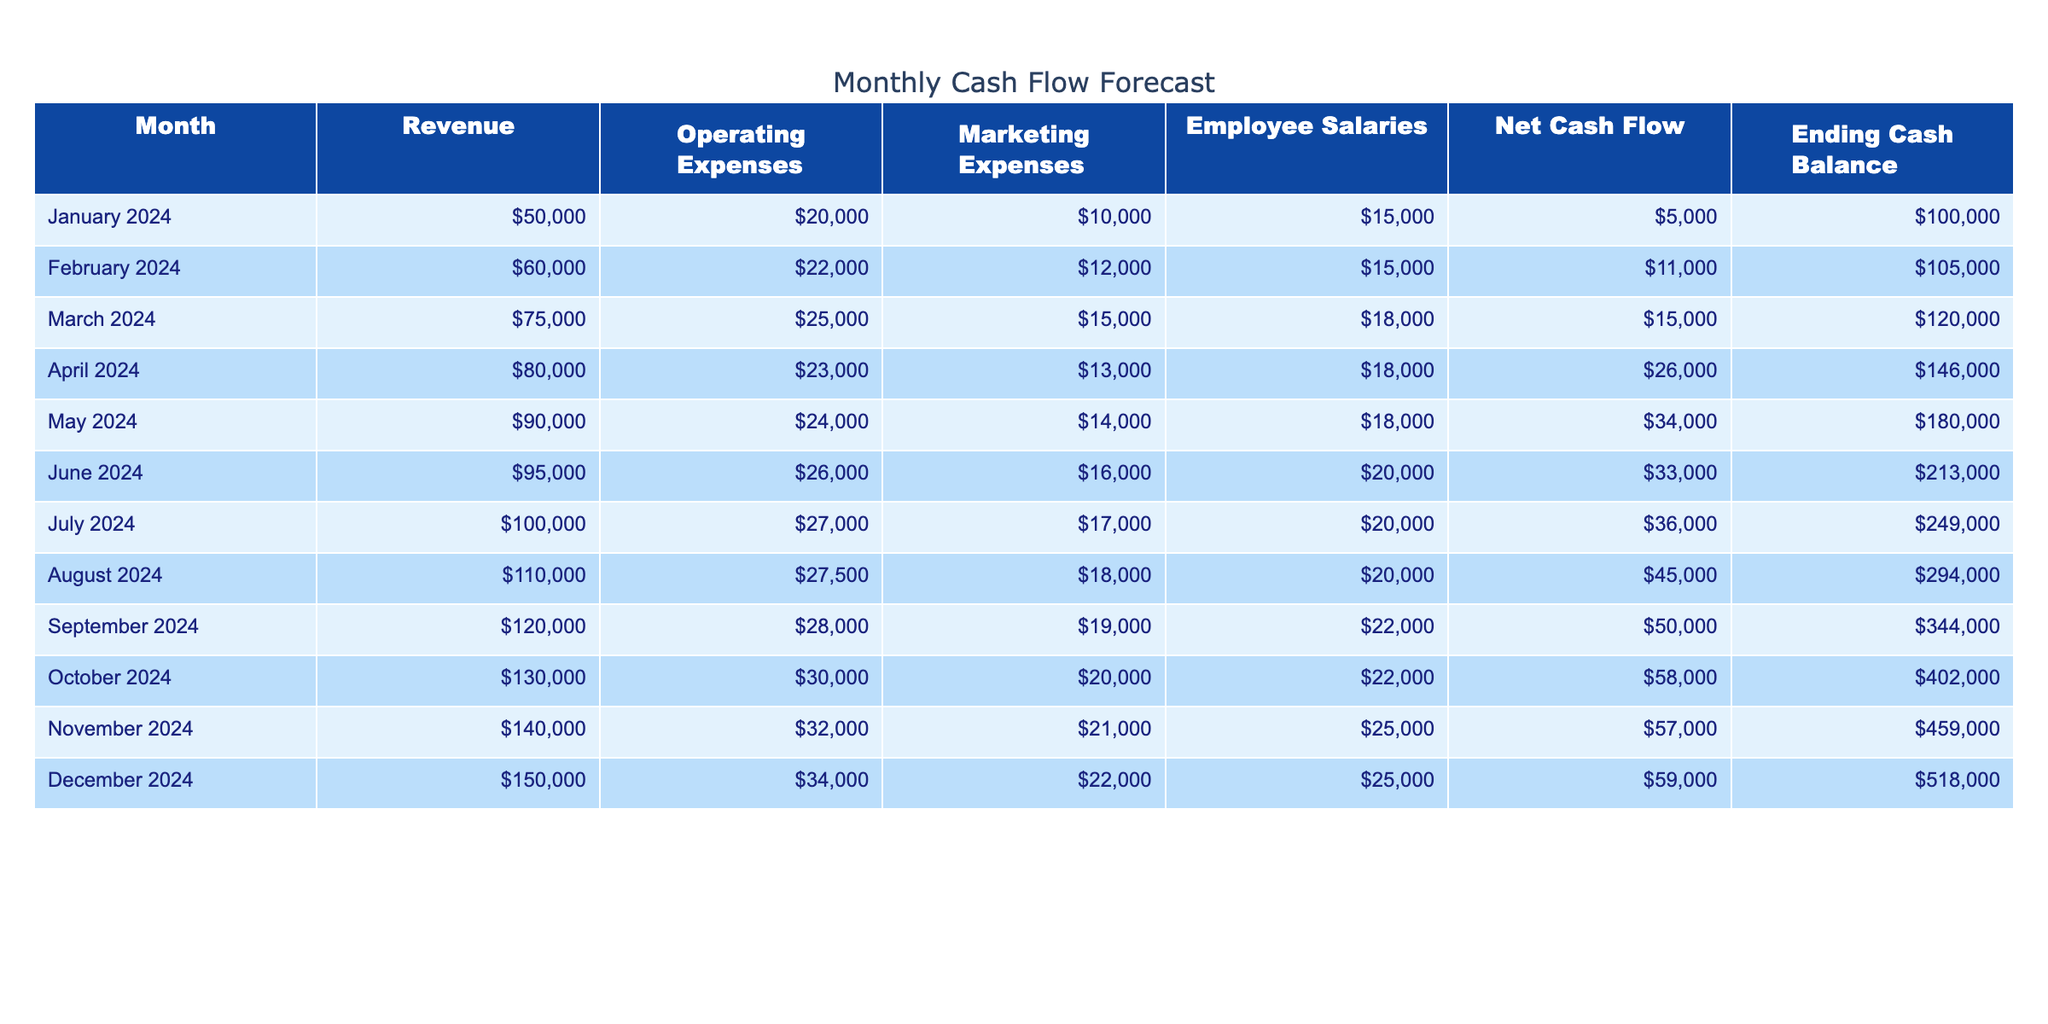What is the total revenue in December 2024? The revenue for December 2024 is listed directly in the table as $150,000.
Answer: $150,000 What were the ending cash balances for the first quarter (January to March 2024)? The ending cash balances for January, February, and March 2024 are $100,000, $105,000, and $120,000 respectively. Thus, for Q1, the ending balances are $100,000, $105,000, and $120,000.
Answer: $100,000, $105,000, $120,000 What is the difference in net cash flow between May 2024 and June 2024? The net cash flow in May 2024 is $34,000 and in June 2024 is $33,000. So, the difference is $34,000 - $33,000 = $1,000.
Answer: $1,000 Did the operating expenses exceed marketing expenses in July 2024? In July 2024, operating expenses are $27,000 and marketing expenses are $17,000. Since $27,000 is greater than $17,000, the statement is true.
Answer: Yes What is the average net cash flow for the entire year 2024? To find the average net cash flow for the year, sum all monthly net cash flows: ($5,000 + $11,000 + $15,000 + $26,000 + $34,000 + $33,000 + $36,000 + $45,000 + $50,000 + $58,000 + $57,000 + $59,000) = $442,000. There are 12 months, so the average is $442,000 / 12 = approximately $36,833.33.
Answer: $36,833.33 What is the trend in employee salaries from January 2024 to December 2024? In January 2024, employee salaries are $15,000 and they increase to $25,000 by December 2024. Therefore, there is a consistent upward trend in employee salaries over the year, indicating growth.
Answer: Upward trend What was the highest net cash flow recorded in any month? The highest net cash flow is in December 2024, which is $59,000.
Answer: $59,000 Is the ending cash balance in October 2024 lower than in November 2024? The ending cash balance for October 2024 is $402,000 and for November 2024 is $459,000. Since $402,000 is less than $459,000, the statement is true.
Answer: Yes What is the total amount spent on marketing expenses over the entire year? The marketing expenses from Jan to Dec 2024 are $10,000 + $12,000 + $15,000 + $13,000 + $14,000 + $16,000 + $17,000 + $18,000 + $19,000 + $20,000 + $21,000 + $22,000, which totals $195,000.
Answer: $195,000 What was the percentage increase in revenue from January 2024 to December 2024? The revenue increased from $50,000 in January to $150,000 in December. The percentage increase is ((150,000 - 50,000) / 50,000) * 100 = 200%.
Answer: 200% What are the highest and lowest ending cash balances throughout the year? The highest ending cash balance is $518,000 in December 2024, and the lowest is $100,000 in January 2024.
Answer: Highest: $518,000, Lowest: $100,000 